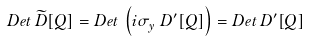Convert formula to latex. <formula><loc_0><loc_0><loc_500><loc_500>D e t \, \widetilde { D } [ Q ] = D e t \, \left ( { i } \sigma ^ { \ } _ { y } D ^ { \prime } [ Q ] \right ) = D e t \, D ^ { \prime } [ Q ]</formula> 